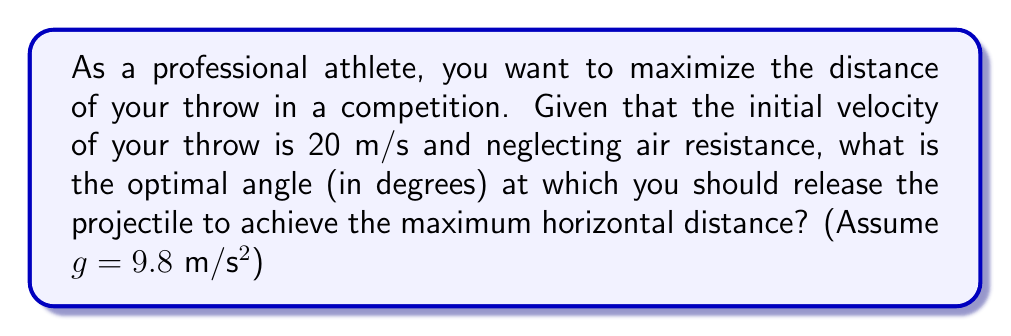Provide a solution to this math problem. To solve this problem, we'll use the principles of projectile motion and optimization.

1) The range (R) of a projectile launched at an angle θ with initial velocity v₀ is given by:

   $$R = \frac{v_0^2 \sin(2\theta)}{g}$$

2) To find the maximum range, we need to maximize sin(2θ). This occurs when sin(2θ) = 1, which happens when 2θ = 90°.

3) Solving for θ:
   $$2\theta = 90°$$
   $$\theta = 45°$$

4) This result is independent of the initial velocity and gravitational acceleration, making it a universal optimal angle for maximum range in ideal conditions.

5) To verify, we can check the range at 45° and compare it to slightly different angles:

   At 44°: $$R = \frac{20^2 \sin(2(44°))}{9.8} \approx 40.65\text{ m}$$
   At 45°: $$R = \frac{20^2 \sin(2(45°))}{9.8} \approx 40.82\text{ m}$$
   At 46°: $$R = \frac{20^2 \sin(2(46°))}{9.8} \approx 40.65\text{ m}$$

This confirms that 45° indeed gives the maximum range.
Answer: 45° 